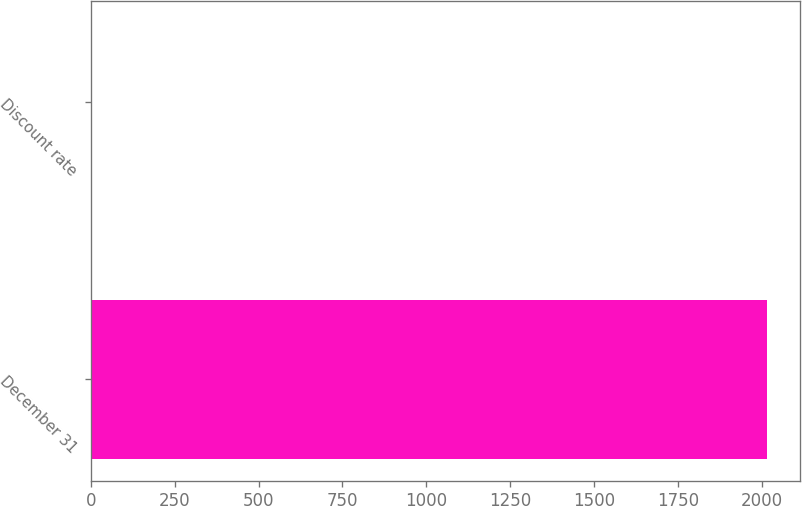Convert chart. <chart><loc_0><loc_0><loc_500><loc_500><bar_chart><fcel>December 31<fcel>Discount rate<nl><fcel>2013<fcel>4.25<nl></chart> 